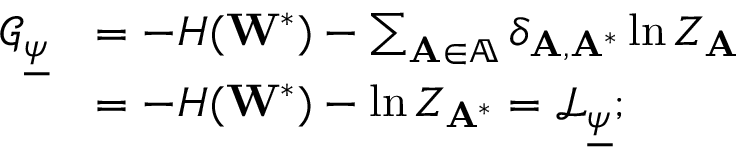<formula> <loc_0><loc_0><loc_500><loc_500>\begin{array} { r l } { \mathcal { G } _ { \underline { \psi } } } & { = - H ( W ^ { * } ) - \sum _ { A \in \mathbb { A } } \delta _ { A , A ^ { * } } \ln Z _ { A } } \\ & { = - H ( W ^ { * } ) - \ln Z _ { A ^ { * } } = \mathcal { L } _ { \underline { \psi } } ; } \end{array}</formula> 